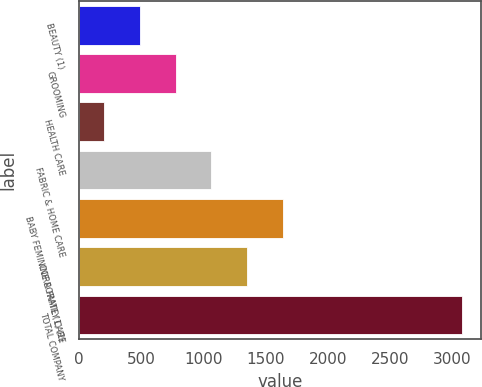Convert chart. <chart><loc_0><loc_0><loc_500><loc_500><bar_chart><fcel>BEAUTY (1)<fcel>GROOMING<fcel>HEALTH CARE<fcel>FABRIC & HOME CARE<fcel>BABY FEMININE & FAMILY CARE<fcel>CORPORATE (1) (2)<fcel>TOTAL COMPANY<nl><fcel>491.4<fcel>778.8<fcel>204<fcel>1066.2<fcel>1641<fcel>1353.6<fcel>3078<nl></chart> 